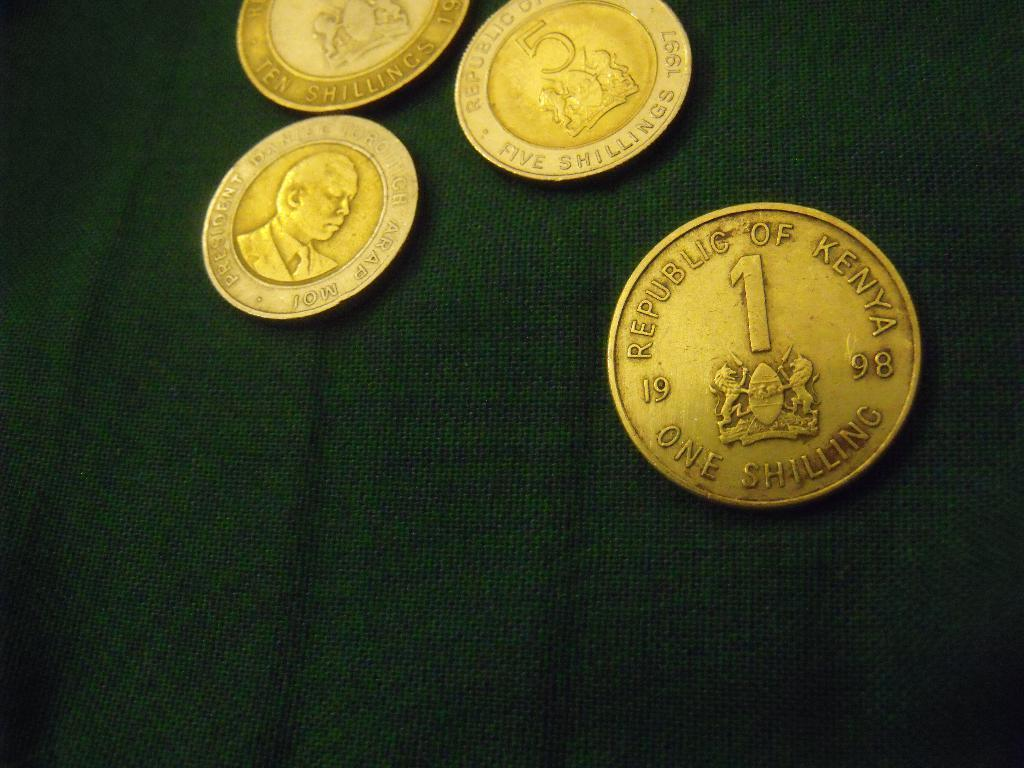<image>
Share a concise interpretation of the image provided. Several gold coins with the closests one from the Republic of Kenya worth one shilling from 1998. 